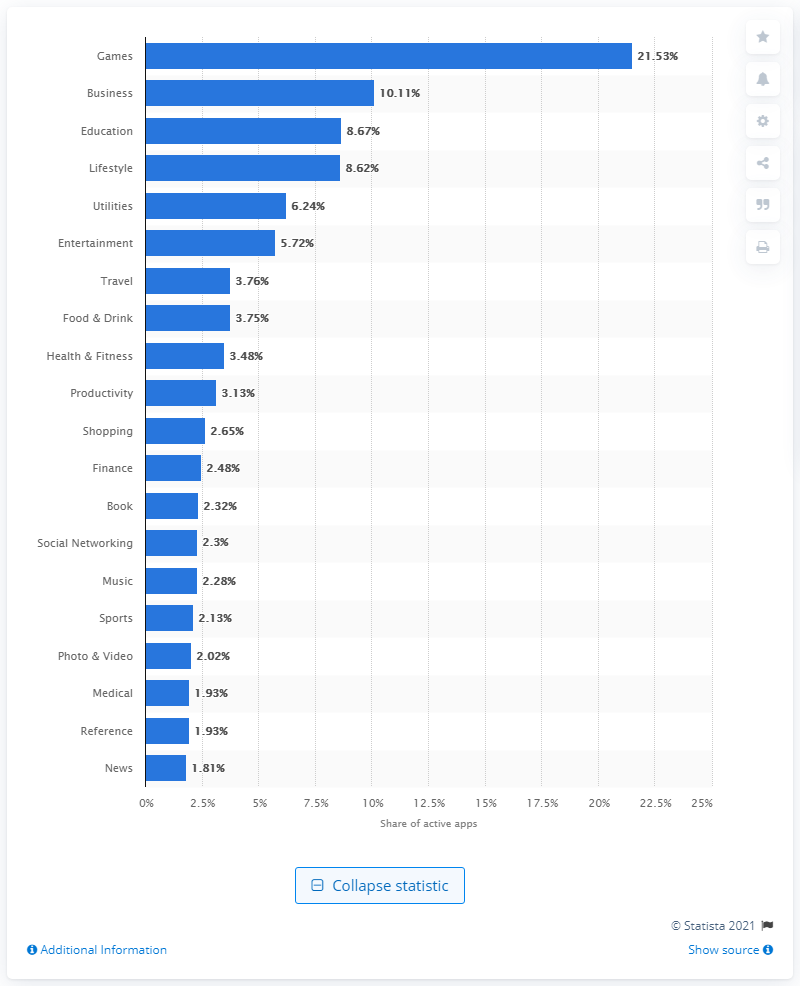Specify some key components in this picture. The most popular iOS app category was games. 